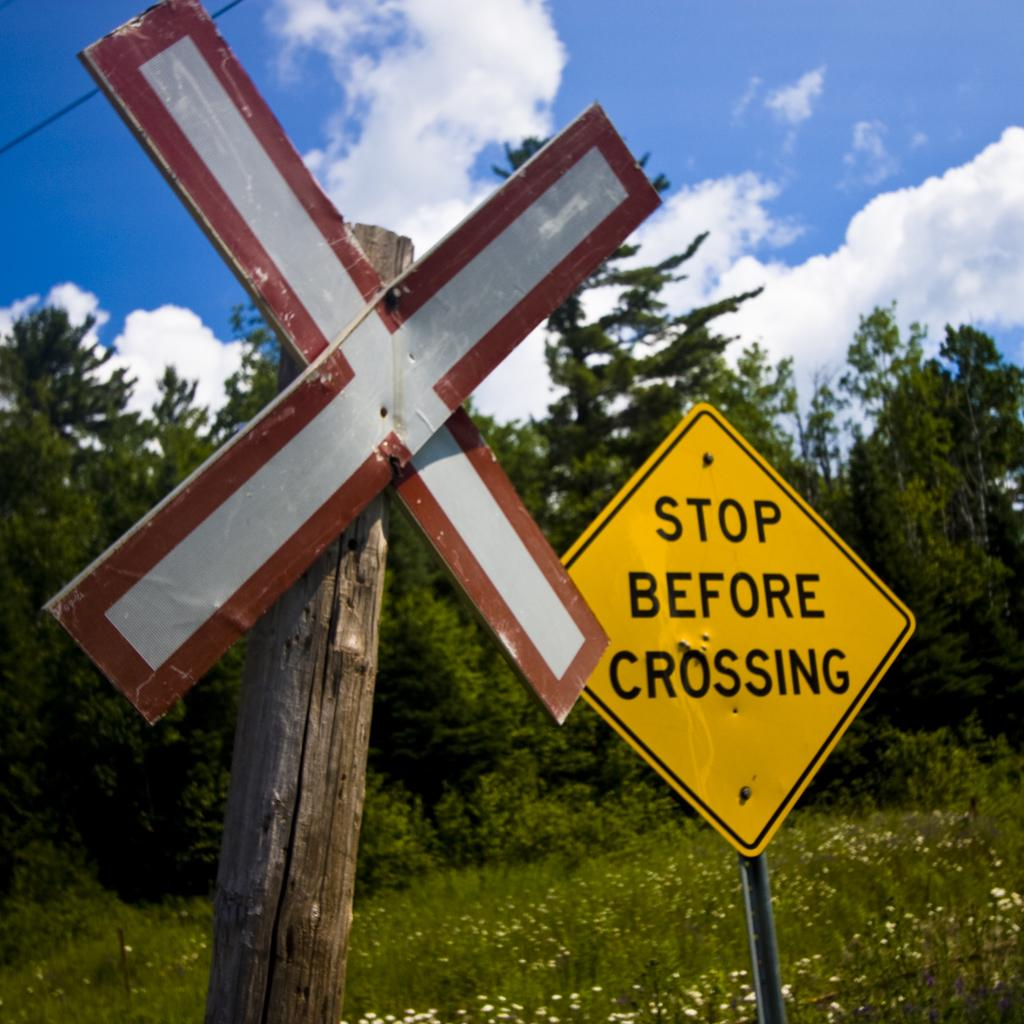<image>
Write a terse but informative summary of the picture. a street sign that is labeled 'stop before crossing' 